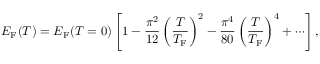<formula> <loc_0><loc_0><loc_500><loc_500>E _ { F } ( T ) = E _ { F } ( T = 0 ) \left [ 1 - { \frac { \pi ^ { 2 } } { 1 2 } } \left ( { \frac { T } { T _ { F } } } \right ) ^ { 2 } - { \frac { \pi ^ { 4 } } { 8 0 } } \left ( { \frac { T } { T _ { F } } } \right ) ^ { 4 } + \cdots \right ] ,</formula> 